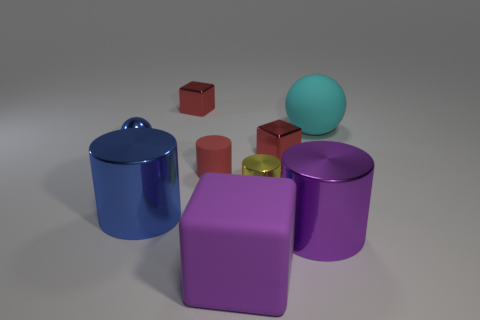Add 1 metal things. How many objects exist? 10 Subtract all blue cylinders. How many cylinders are left? 3 Subtract all red cubes. How many cubes are left? 1 Subtract 1 blocks. How many blocks are left? 2 Subtract all gray balls. How many red blocks are left? 2 Subtract all small yellow cylinders. Subtract all small metal cylinders. How many objects are left? 7 Add 1 small metal spheres. How many small metal spheres are left? 2 Add 6 green metal cylinders. How many green metal cylinders exist? 6 Subtract 1 red cylinders. How many objects are left? 8 Subtract all balls. How many objects are left? 7 